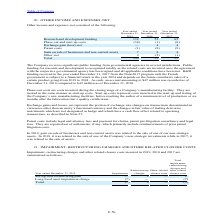According to Stmicroelectronics's financial document, Which government supported the R&D funding? According to the financial document, French government. The relevant text states: "ember 31, 2017 from the Nano2017 program with the French government is subject to a financial return in the year 2024 and depends on the future cumulative sales of a c..." Also, What are start-up costs? Start-up costs represent costs incurred in the start-up and testing of the Company’s new manufacturing facilities, before reaching the earlier of a minimum level of production or six months after the fabrication line’s quality certification.. The document states: "are treated in the same manner as start-up costs. Start-up costs represent costs incurred in the start-up and testing of the Company’s new manufacturi..." Also, What is included in the patent costs? Patent costs include legal and attorney fees and payment for claims, patent pre-litigation consultancy and legal fees.. The document states: "Patent costs include legal and attorney fees and payment for claims, patent pre-litigation consultancy and legal fees. They are reported net of settle..." Also, can you calculate: What is the average Research and development funding? To answer this question, I need to perform calculations using the financial data. The calculation is: (132+52+65) / 3, which equals 83. This is based on the information: "Research and development funding 132 52 65 Research and development funding 132 52 65 Research and development funding 132 52 65..." The key data points involved are: 132, 52, 65. Also, can you calculate: What is the average Phase-out and start-up costs? To answer this question, I need to perform calculations using the financial data. The calculation is: (38+1+8) / 3, which equals 15.67. This is based on the information: "Phase-out and start-up costs (38) (1) (8) Phase-out and start-up costs (38) (1) (8) Year ended December 31,..." The key data points involved are: 38, 8. Also, can you calculate: What is the average Patent costs? To answer this question, I need to perform calculations using the financial data. The calculation is: (1+8+9) / 3, which equals 6. This is based on the information: "Year ended December 31, Year ended December 31, Year ended December 31,..." The key data points involved are: 1, 8, 9. 